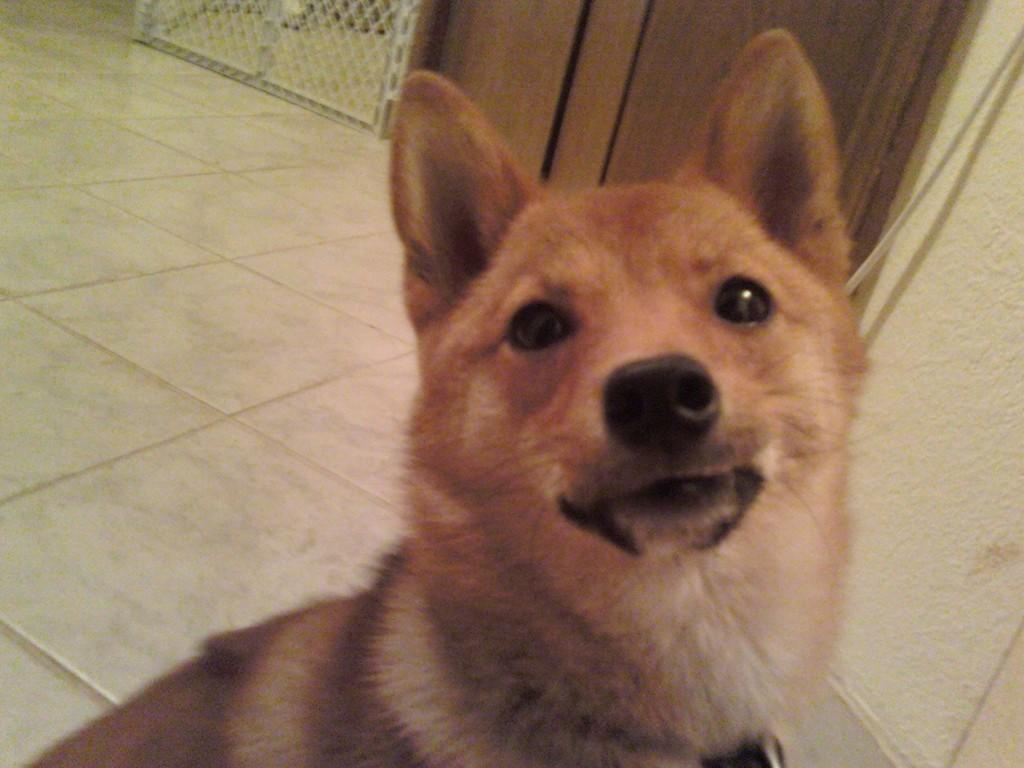What type of flooring is present in the image? The image contains a tile floor. What animal can be seen in the image? There is a brown dog in the image. What type of furniture is visible in the background of the image? There is a wooden cupboard in the background of the image. What architectural feature can be seen in the image? There is a railing visible in the image. What type of arm is visible in the image? There is no arm visible in the image. 